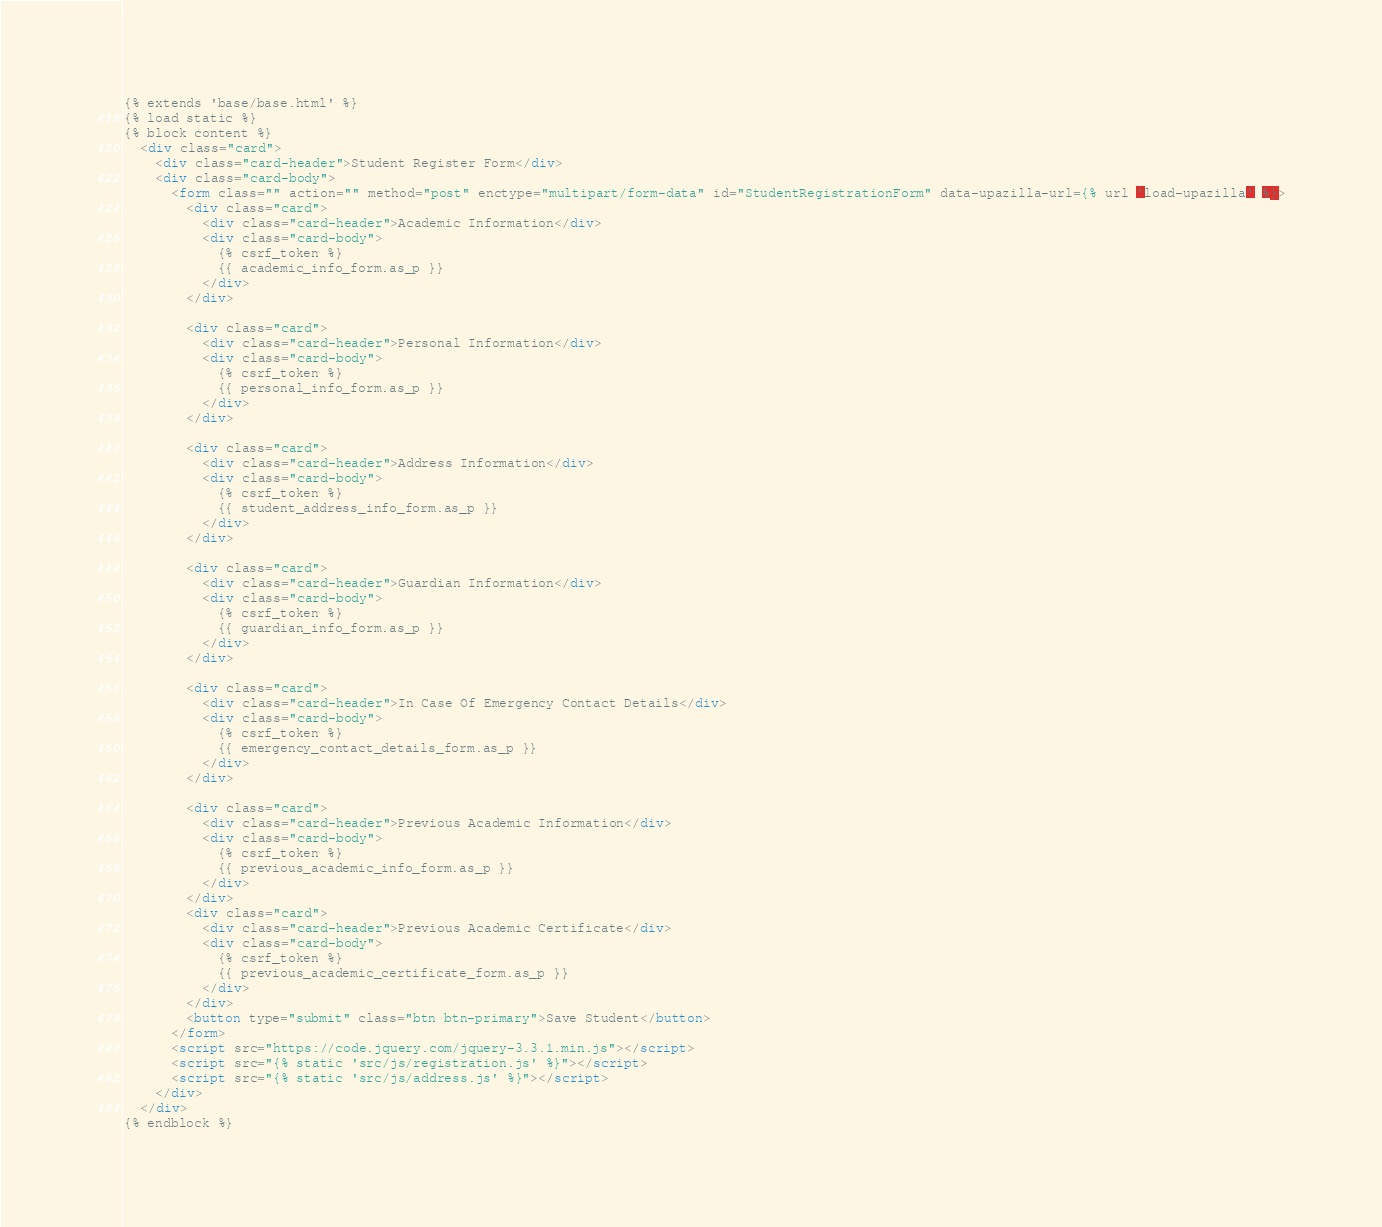<code> <loc_0><loc_0><loc_500><loc_500><_HTML_>{% extends 'base/base.html' %}
{% load static %}
{% block content %}
  <div class="card">
    <div class="card-header">Student Register Form</div>
    <div class="card-body">
      <form class="" action="" method="post" enctype="multipart/form-data" id="StudentRegistrationForm" data-upazilla-url={% url 'load-upazilla' %}>
        <div class="card">
          <div class="card-header">Academic Information</div>
          <div class="card-body">
            {% csrf_token %}
            {{ academic_info_form.as_p }}
          </div>
        </div>

        <div class="card">
          <div class="card-header">Personal Information</div>
          <div class="card-body">
            {% csrf_token %}
            {{ personal_info_form.as_p }}
          </div>
        </div>

        <div class="card">
          <div class="card-header">Address Information</div>
          <div class="card-body">
            {% csrf_token %}
            {{ student_address_info_form.as_p }}
          </div>
        </div>

        <div class="card">
          <div class="card-header">Guardian Information</div>
          <div class="card-body">
            {% csrf_token %}
            {{ guardian_info_form.as_p }}
          </div>
        </div>

        <div class="card">
          <div class="card-header">In Case Of Emergency Contact Details</div>
          <div class="card-body">
            {% csrf_token %}
            {{ emergency_contact_details_form.as_p }}
          </div>
        </div>

        <div class="card">
          <div class="card-header">Previous Academic Information</div>
          <div class="card-body">
            {% csrf_token %}
            {{ previous_academic_info_form.as_p }}
          </div>
        </div>
        <div class="card">
          <div class="card-header">Previous Academic Certificate</div>
          <div class="card-body">
            {% csrf_token %}
            {{ previous_academic_certificate_form.as_p }}
          </div>
        </div>
        <button type="submit" class="btn btn-primary">Save Student</button>
      </form>
      <script src="https://code.jquery.com/jquery-3.3.1.min.js"></script>
      <script src="{% static 'src/js/registration.js' %}"></script>
      <script src="{% static 'src/js/address.js' %}"></script>
    </div>
  </div>
{% endblock %}
</code> 